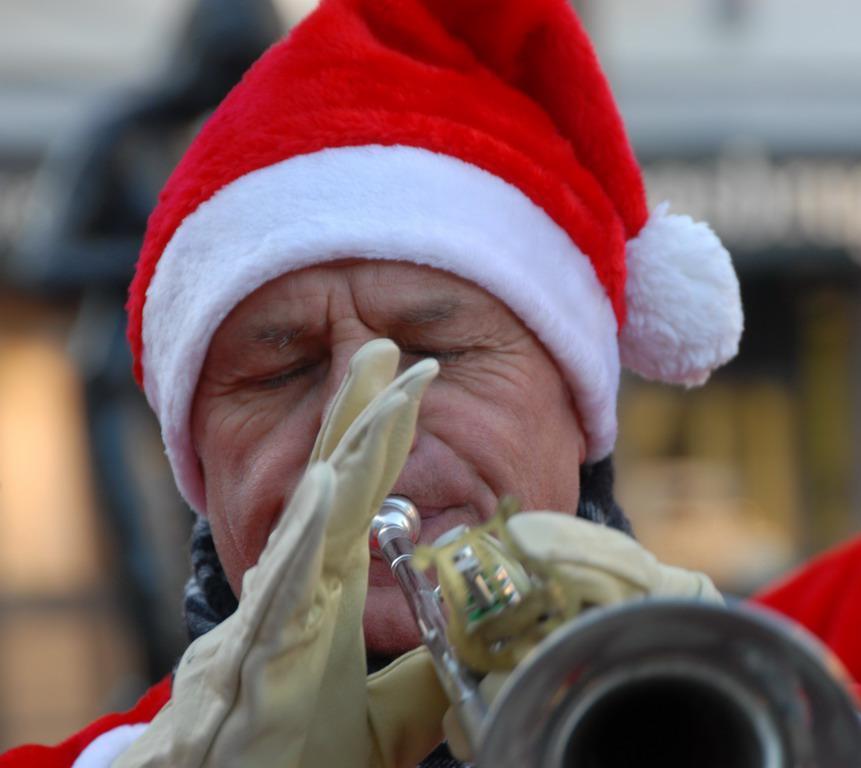How would you summarize this image in a sentence or two? In the picture I can see a person holding a musical instrument in his hands and there are some other objects in the background. 